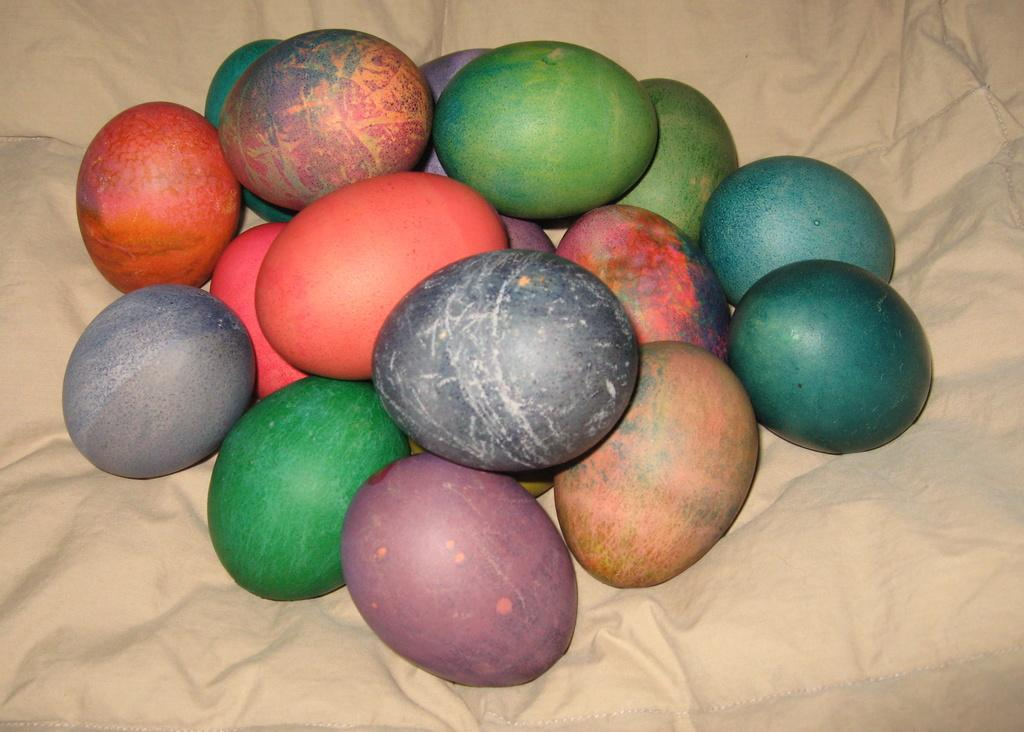What is present in the image that can be eaten? There are eggs in the image that can be eaten. What distinguishes the eggs from one another? The eggs are in different colors. How are the eggs displayed in the image? The eggs are arranged on a cloth. What is the color of the background in the image? The background of the image is cream in color. What type of knowledge can be gained from the eggs in the image? The eggs in the image do not convey any specific knowledge; they are simply eggs of different colors arranged on a cloth. 